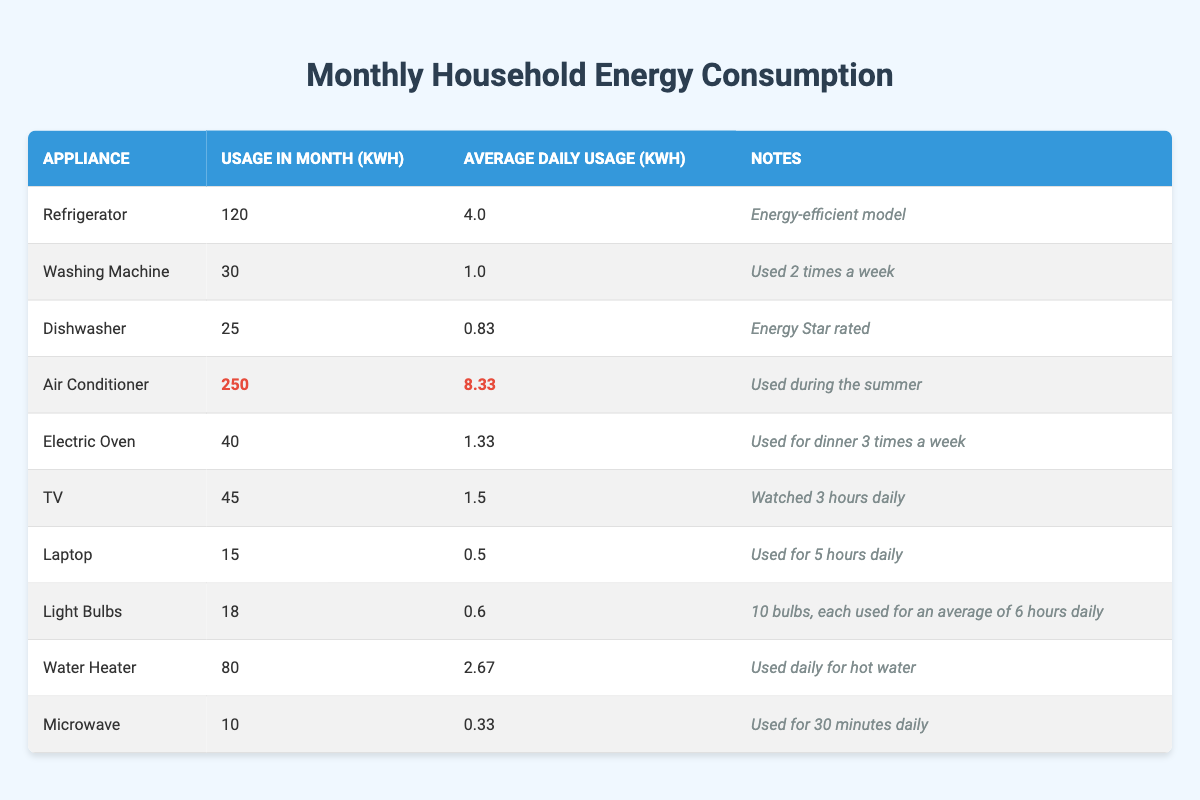What is the total energy consumption for all appliances? To find the total energy consumption, we sum the usage_in_month values for all appliances (120 + 30 + 25 + 250 + 40 + 45 + 15 + 18 + 80 + 10 = 628 kWh).
Answer: 628 kWh Which appliance consumes the least energy in a month? By examining the usage_in_month column, the Microwave shows the lowest value at 10 kWh.
Answer: Microwave What is the average daily usage of the Air Conditioner? The average daily usage for the Air Conditioner is explicitly provided in the table as 8.33 kWh/day.
Answer: 8.33 kWh How much more energy does the Air Conditioner use compared to the Dishwasher? The Air Conditioner's usage is 250 kWh, while the Dishwasher's is 25 kWh. The difference is 250 - 25 = 225 kWh.
Answer: 225 kWh What is the average energy consumption across all appliances for the month? To find the average, calculate the total energy consumption (628 kWh) and divide by the number of appliances (10). This gives us 628 / 10 = 62.8 kWh.
Answer: 62.8 kWh Are there any appliances that use energy less than 20 kWh in a month? Checking the usage_in_month values, both the Laptop (15 kWh) and the Microwave (10 kWh) fall below 20 kWh.
Answer: Yes What percentage of the total energy consumption is attributed to the Air Conditioner? Calculate the percentage by dividing the Air Conditioner’s consumption by the total consumption and multiplying by 100: (250 / 628) * 100 ≈ 39.84%.
Answer: ≈ 39.84% Which appliances are rated as energy-efficient or have notable features? The Refrigerator is noted as an "Energy-efficient model," and the Dishwasher is "Energy Star rated," highlighting their efficiency.
Answer: Refrigerator and Dishwasher What is the cumulative daily usage of the Electric Oven and the TV? The average daily usage of the Electric Oven is 1.33 kWh, and the TV’s is 1.5 kWh. Adding these together gives us 1.33 + 1.5 = 2.83 kWh.
Answer: 2.83 kWh If the Water Heater were to be used for one additional hour daily, how much extra energy would it consume in a month? The additional usage would be 2.67 kWh (current average) plus the energy for one extra hour. If the daily consumption remains constant, it would be 2.67 + 2.67/24 = 2.67 + 0.11 ≈ 2.78 kWh/day. Over 30 days, the extra would be (2.78 - 2.67) * 30 = 3.3 kWh.
Answer: 3.3 kWh 